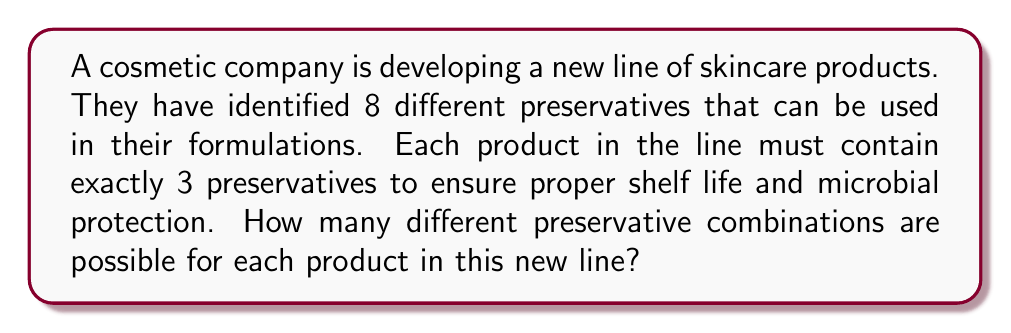Could you help me with this problem? To solve this problem, we need to use the combination formula, as the order of selection doesn't matter (i.e., preservatives A, B, and C would be considered the same combination as B, C, and A).

1. We have:
   - Total number of preservatives (n) = 8
   - Number of preservatives to be selected for each product (r) = 3

2. The combination formula is:

   $$C(n,r) = \frac{n!}{r!(n-r)!}$$

3. Substituting our values:

   $$C(8,3) = \frac{8!}{3!(8-3)!} = \frac{8!}{3!5!}$$

4. Expand this:
   $$\frac{8 \times 7 \times 6 \times 5!}{(3 \times 2 \times 1) \times 5!}$$

5. The 5! cancels out in the numerator and denominator:
   $$\frac{8 \times 7 \times 6}{3 \times 2 \times 1}$$

6. Multiply the numerator and denominator:
   $$\frac{336}{6}$$

7. Divide:
   $$56$$

Therefore, there are 56 different possible combinations of preservatives for each product in the new line.
Answer: 56 